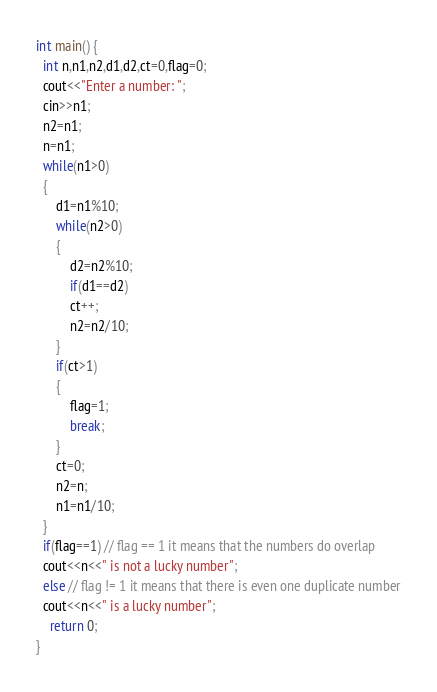Convert code to text. <code><loc_0><loc_0><loc_500><loc_500><_C++_>int main() {
  int n,n1,n2,d1,d2,ct=0,flag=0;
  cout<<"Enter a number: ";
  cin>>n1;
  n2=n1;
  n=n1;
  while(n1>0) 
  {
      d1=n1%10;
      while(n2>0) 
      {
          d2=n2%10;
          if(d1==d2)
          ct++;
          n2=n2/10;
      }
      if(ct>1)
      {
          flag=1;
          break;
      }
      ct=0;
      n2=n;
      n1=n1/10;
  }
  if(flag==1) // flag == 1 it means that the numbers do overlap
  cout<<n<<" is not a lucky number";
  else // flag != 1 it means that there is even one duplicate number
  cout<<n<<" is a lucky number";
    return 0;
}</code> 